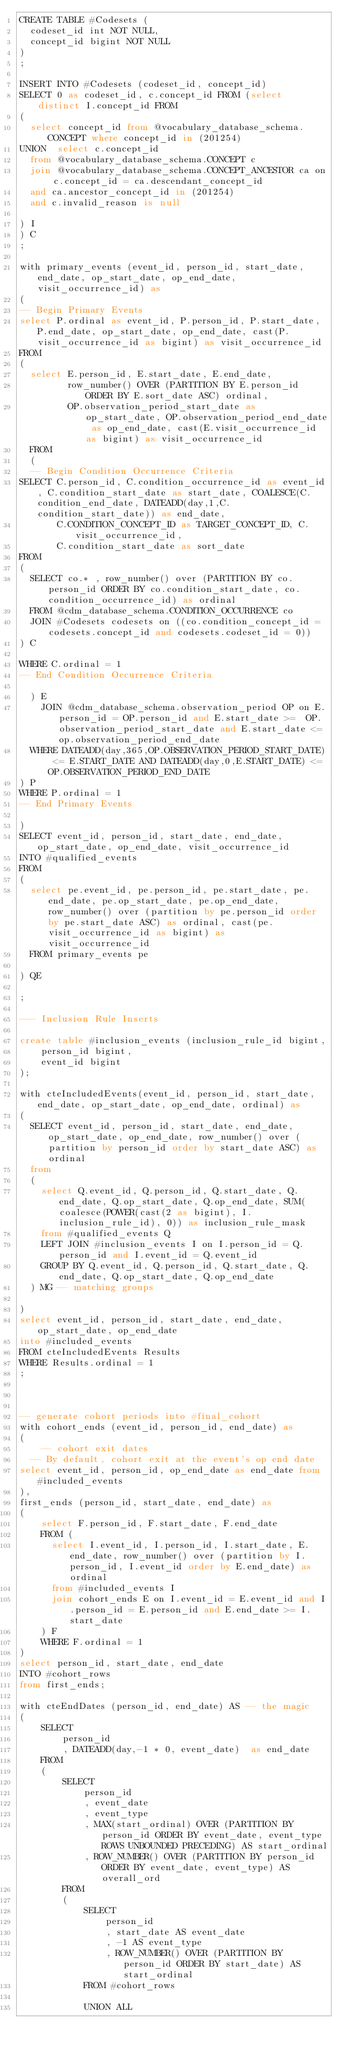Convert code to text. <code><loc_0><loc_0><loc_500><loc_500><_SQL_>CREATE TABLE #Codesets (
  codeset_id int NOT NULL,
  concept_id bigint NOT NULL
)
;

INSERT INTO #Codesets (codeset_id, concept_id)
SELECT 0 as codeset_id, c.concept_id FROM (select distinct I.concept_id FROM
( 
  select concept_id from @vocabulary_database_schema.CONCEPT where concept_id in (201254)
UNION  select c.concept_id
  from @vocabulary_database_schema.CONCEPT c
  join @vocabulary_database_schema.CONCEPT_ANCESTOR ca on c.concept_id = ca.descendant_concept_id
  and ca.ancestor_concept_id in (201254)
  and c.invalid_reason is null

) I
) C
;

with primary_events (event_id, person_id, start_date, end_date, op_start_date, op_end_date, visit_occurrence_id) as
(
-- Begin Primary Events
select P.ordinal as event_id, P.person_id, P.start_date, P.end_date, op_start_date, op_end_date, cast(P.visit_occurrence_id as bigint) as visit_occurrence_id
FROM
(
  select E.person_id, E.start_date, E.end_date,
         row_number() OVER (PARTITION BY E.person_id ORDER BY E.sort_date ASC) ordinal,
         OP.observation_period_start_date as op_start_date, OP.observation_period_end_date as op_end_date, cast(E.visit_occurrence_id as bigint) as visit_occurrence_id
  FROM 
  (
  -- Begin Condition Occurrence Criteria
SELECT C.person_id, C.condition_occurrence_id as event_id, C.condition_start_date as start_date, COALESCE(C.condition_end_date, DATEADD(day,1,C.condition_start_date)) as end_date,
       C.CONDITION_CONCEPT_ID as TARGET_CONCEPT_ID, C.visit_occurrence_id,
       C.condition_start_date as sort_date
FROM 
(
  SELECT co.* , row_number() over (PARTITION BY co.person_id ORDER BY co.condition_start_date, co.condition_occurrence_id) as ordinal
  FROM @cdm_database_schema.CONDITION_OCCURRENCE co
  JOIN #Codesets codesets on ((co.condition_concept_id = codesets.concept_id and codesets.codeset_id = 0))
) C

WHERE C.ordinal = 1
-- End Condition Occurrence Criteria

  ) E
	JOIN @cdm_database_schema.observation_period OP on E.person_id = OP.person_id and E.start_date >=  OP.observation_period_start_date and E.start_date <= op.observation_period_end_date
  WHERE DATEADD(day,365,OP.OBSERVATION_PERIOD_START_DATE) <= E.START_DATE AND DATEADD(day,0,E.START_DATE) <= OP.OBSERVATION_PERIOD_END_DATE
) P
WHERE P.ordinal = 1
-- End Primary Events

)
SELECT event_id, person_id, start_date, end_date, op_start_date, op_end_date, visit_occurrence_id
INTO #qualified_events
FROM 
(
  select pe.event_id, pe.person_id, pe.start_date, pe.end_date, pe.op_start_date, pe.op_end_date, row_number() over (partition by pe.person_id order by pe.start_date ASC) as ordinal, cast(pe.visit_occurrence_id as bigint) as visit_occurrence_id
  FROM primary_events pe
  
) QE

;

--- Inclusion Rule Inserts

create table #inclusion_events (inclusion_rule_id bigint,
	person_id bigint,
	event_id bigint
);

with cteIncludedEvents(event_id, person_id, start_date, end_date, op_start_date, op_end_date, ordinal) as
(
  SELECT event_id, person_id, start_date, end_date, op_start_date, op_end_date, row_number() over (partition by person_id order by start_date ASC) as ordinal
  from
  (
    select Q.event_id, Q.person_id, Q.start_date, Q.end_date, Q.op_start_date, Q.op_end_date, SUM(coalesce(POWER(cast(2 as bigint), I.inclusion_rule_id), 0)) as inclusion_rule_mask
    from #qualified_events Q
    LEFT JOIN #inclusion_events I on I.person_id = Q.person_id and I.event_id = Q.event_id
    GROUP BY Q.event_id, Q.person_id, Q.start_date, Q.end_date, Q.op_start_date, Q.op_end_date
  ) MG -- matching groups

)
select event_id, person_id, start_date, end_date, op_start_date, op_end_date
into #included_events
FROM cteIncludedEvents Results
WHERE Results.ordinal = 1
;



-- generate cohort periods into #final_cohort
with cohort_ends (event_id, person_id, end_date) as
(
	-- cohort exit dates
  -- By default, cohort exit at the event's op end date
select event_id, person_id, op_end_date as end_date from #included_events
),
first_ends (person_id, start_date, end_date) as
(
	select F.person_id, F.start_date, F.end_date
	FROM (
	  select I.event_id, I.person_id, I.start_date, E.end_date, row_number() over (partition by I.person_id, I.event_id order by E.end_date) as ordinal 
	  from #included_events I
	  join cohort_ends E on I.event_id = E.event_id and I.person_id = E.person_id and E.end_date >= I.start_date
	) F
	WHERE F.ordinal = 1
)
select person_id, start_date, end_date
INTO #cohort_rows
from first_ends;

with cteEndDates (person_id, end_date) AS -- the magic
(	
	SELECT
		person_id
		, DATEADD(day,-1 * 0, event_date)  as end_date
	FROM
	(
		SELECT
			person_id
			, event_date
			, event_type
			, MAX(start_ordinal) OVER (PARTITION BY person_id ORDER BY event_date, event_type ROWS UNBOUNDED PRECEDING) AS start_ordinal 
			, ROW_NUMBER() OVER (PARTITION BY person_id ORDER BY event_date, event_type) AS overall_ord
		FROM
		(
			SELECT
				person_id
				, start_date AS event_date
				, -1 AS event_type
				, ROW_NUMBER() OVER (PARTITION BY person_id ORDER BY start_date) AS start_ordinal
			FROM #cohort_rows
		
			UNION ALL</code> 